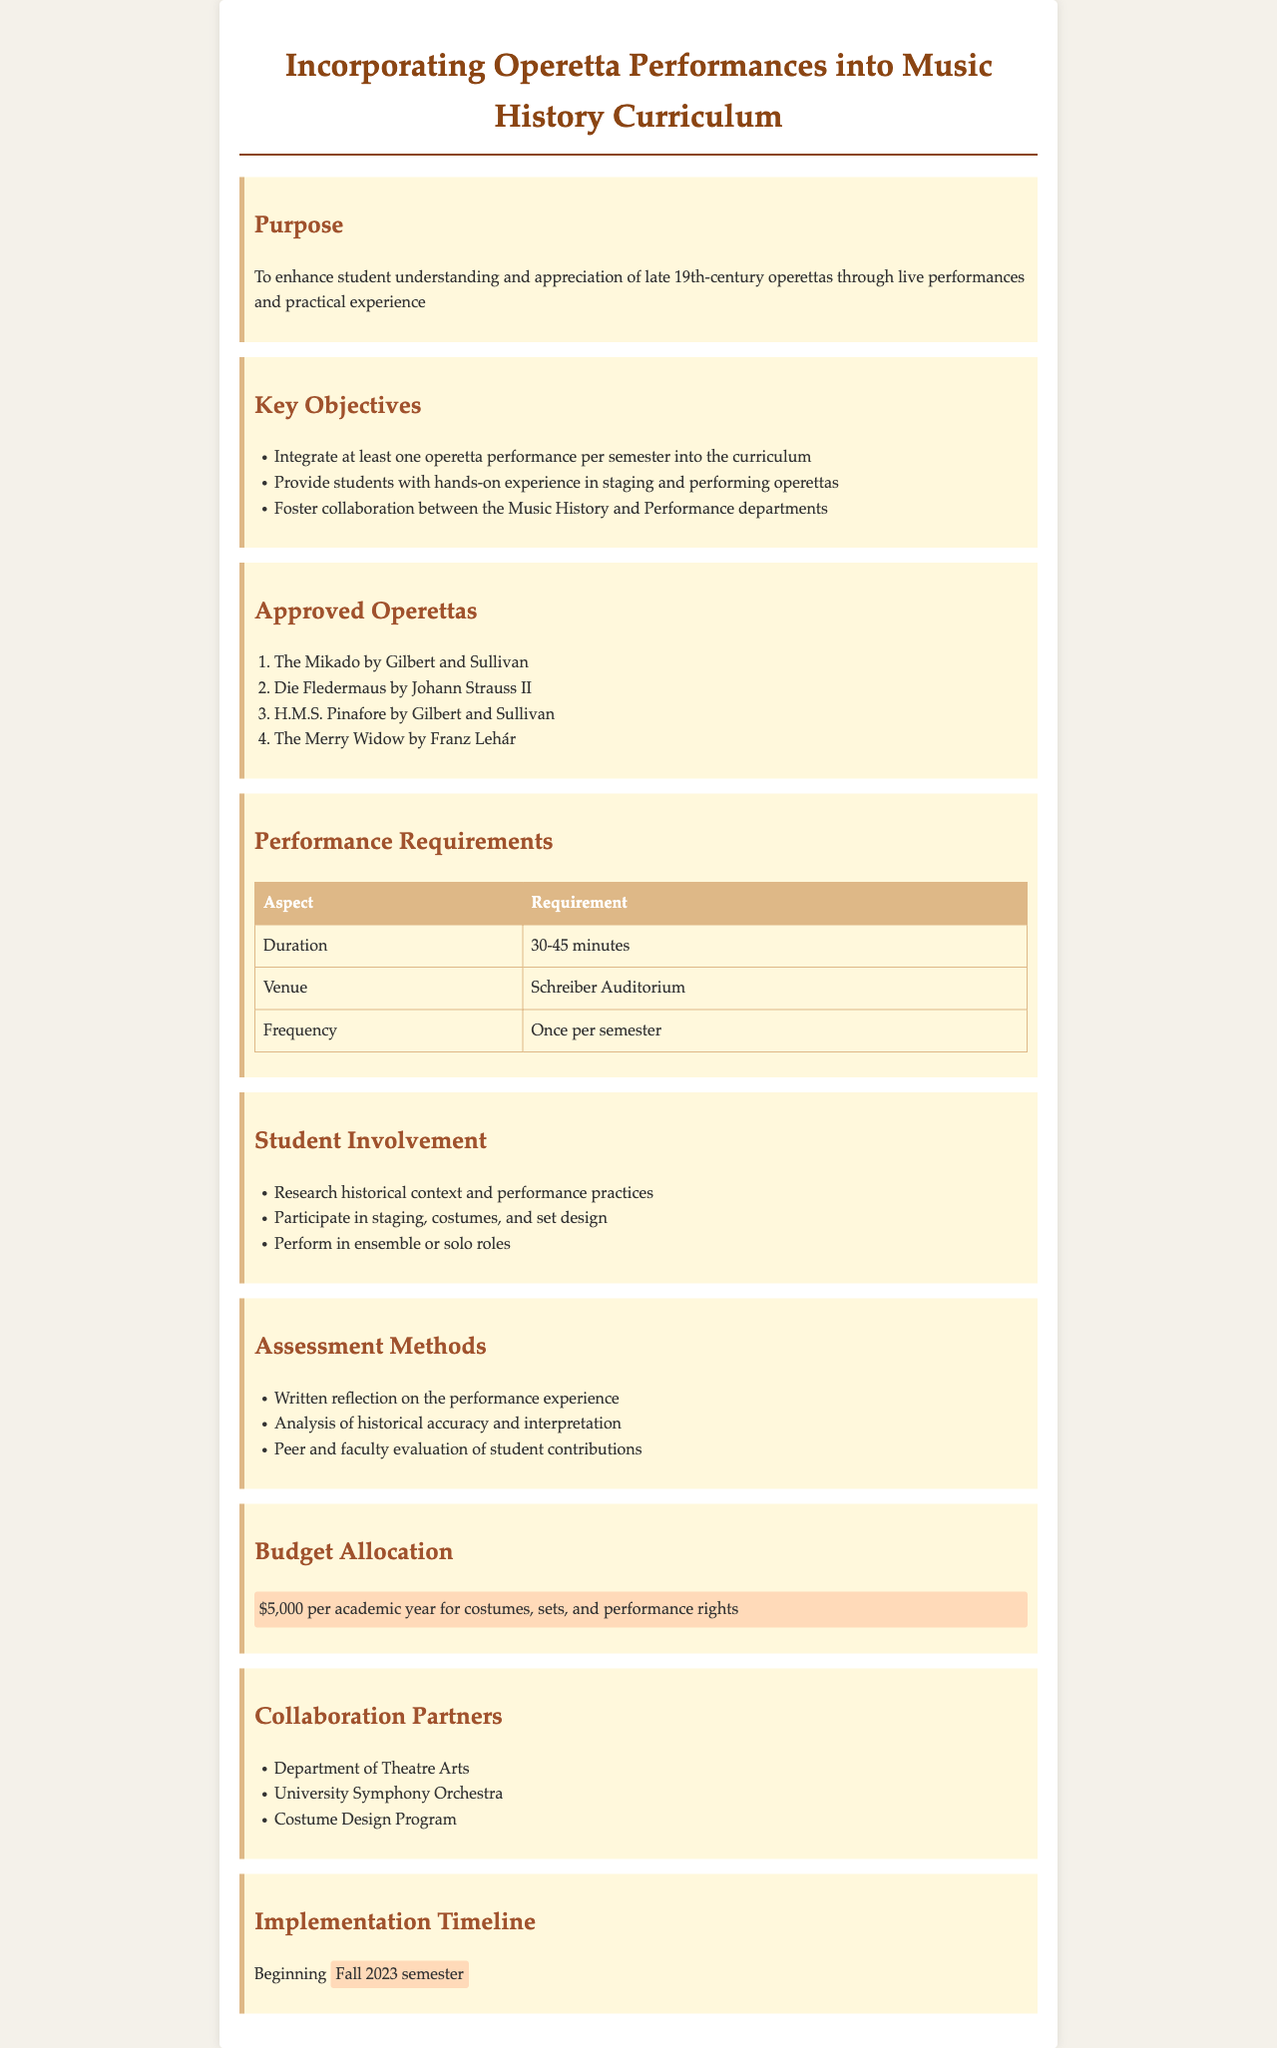What is the purpose of the document? The purpose outlined in the document emphasizes enhancing student understanding and appreciation of late 19th-century operettas through live performances and practical experience.
Answer: To enhance student understanding and appreciation of late 19th-century operettas through live performances and practical experience How many operetta performances are required per semester? The document states that there should be at least one operetta performance integrated into the curriculum each semester.
Answer: One What is the budget allocated for costumes, sets, and performance rights? The budget allocation section specifies a yearly budget for specific expenses related to operettas.
Answer: $5,000 Name one approved operetta listed in the document. The document includes a list of approved operettas, and any one of them can be named as an example.
Answer: The Mikado What is the required duration for the operetta performance? The performance requirements section indicates the expected duration of the performances in minutes.
Answer: 30-45 minutes Which department collaborates with the Music History department? The document lists several collaboration partners, naming one will highlight the collaborative aspect of the initiative.
Answer: Department of Theatre Arts In what semester does the implementation of this policy begin? The implementation timeline specifies the start of the policy in the Fall semester of a certain academic year.
Answer: Fall 2023 semester What type of assessment method involves peer evaluation? The assessment methods section describes various evaluation methods, among which one involves peer assessment.
Answer: Peer and faculty evaluation of student contributions How will students be involved in the productions? The document lists specific activities that students will participate in for the operetta productions.
Answer: Research historical context and performance practices 